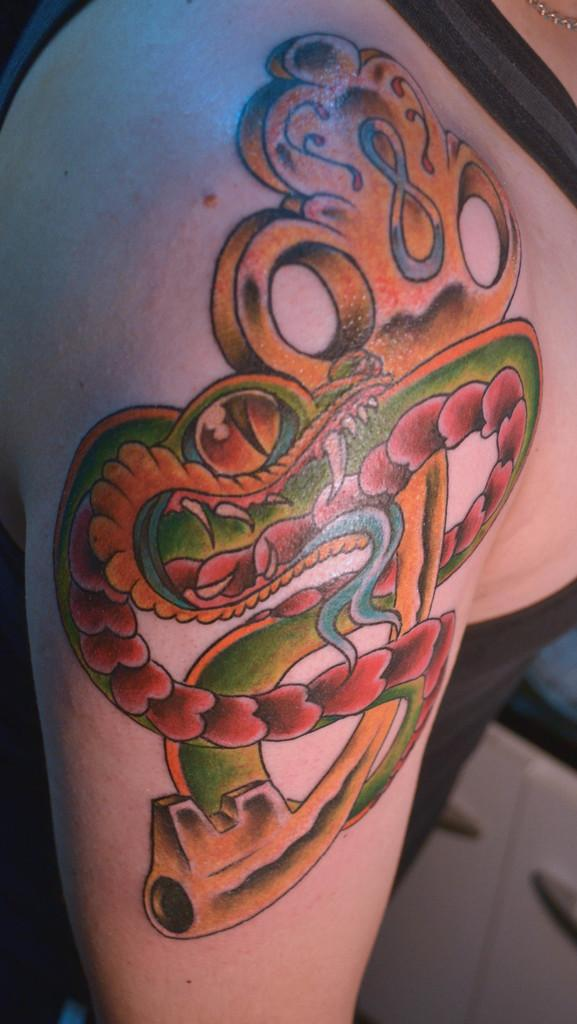What is the main subject of the image? There is a person in the image. Can you describe the person's position in the image? The person is standing in the front. Are there any distinguishing features on the person's body? Yes, the person has a tattoo on her shoulder. What type of rail can be seen near the person in the image? There is no rail present in the image. Can you describe the beetle that is crawling on the person's shoulder in the image? There is no beetle present on the person's shoulder in the image. 